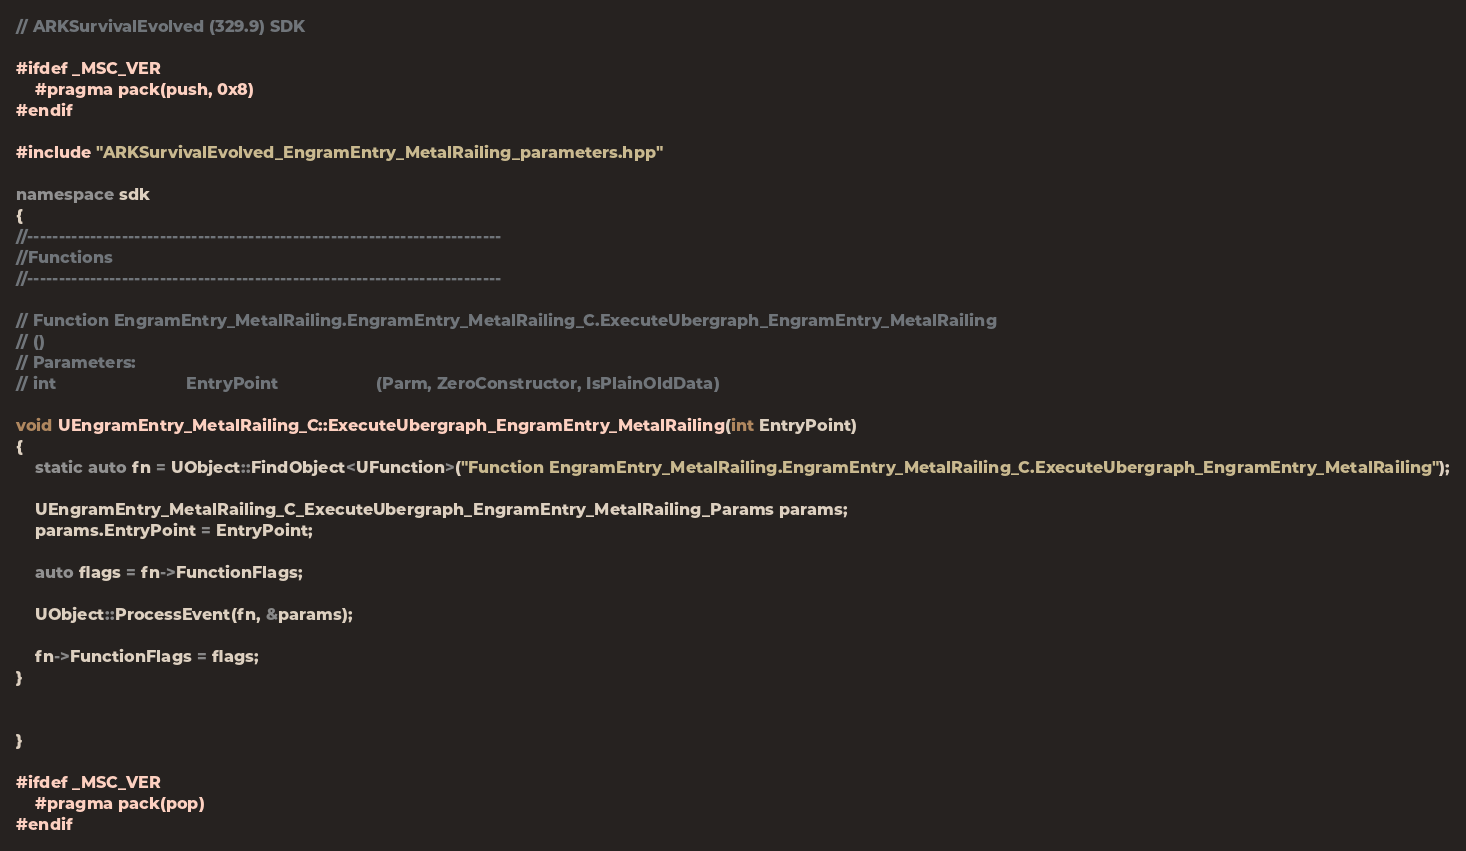Convert code to text. <code><loc_0><loc_0><loc_500><loc_500><_C++_>// ARKSurvivalEvolved (329.9) SDK

#ifdef _MSC_VER
	#pragma pack(push, 0x8)
#endif

#include "ARKSurvivalEvolved_EngramEntry_MetalRailing_parameters.hpp"

namespace sdk
{
//---------------------------------------------------------------------------
//Functions
//---------------------------------------------------------------------------

// Function EngramEntry_MetalRailing.EngramEntry_MetalRailing_C.ExecuteUbergraph_EngramEntry_MetalRailing
// ()
// Parameters:
// int                            EntryPoint                     (Parm, ZeroConstructor, IsPlainOldData)

void UEngramEntry_MetalRailing_C::ExecuteUbergraph_EngramEntry_MetalRailing(int EntryPoint)
{
	static auto fn = UObject::FindObject<UFunction>("Function EngramEntry_MetalRailing.EngramEntry_MetalRailing_C.ExecuteUbergraph_EngramEntry_MetalRailing");

	UEngramEntry_MetalRailing_C_ExecuteUbergraph_EngramEntry_MetalRailing_Params params;
	params.EntryPoint = EntryPoint;

	auto flags = fn->FunctionFlags;

	UObject::ProcessEvent(fn, &params);

	fn->FunctionFlags = flags;
}


}

#ifdef _MSC_VER
	#pragma pack(pop)
#endif
</code> 